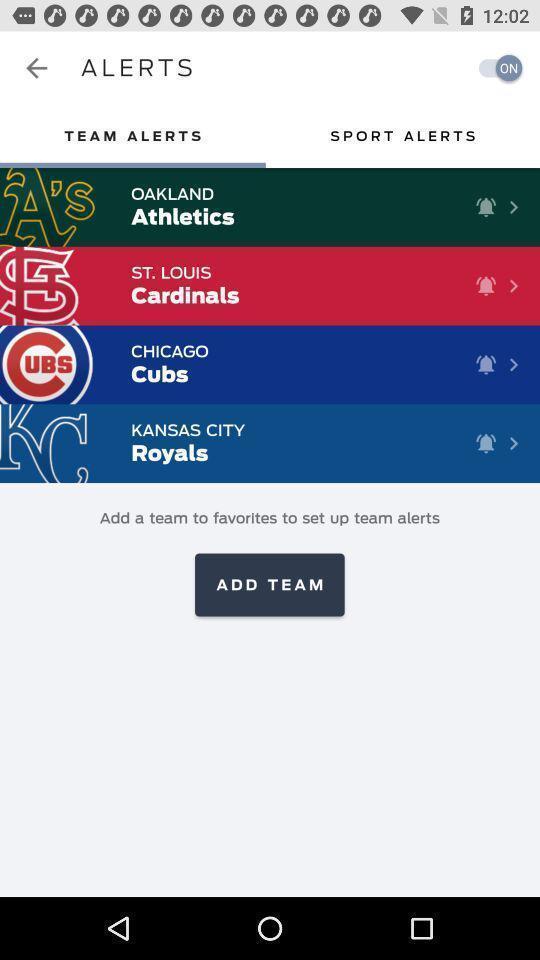Please provide a description for this image. Setting up alerts for different teams. 